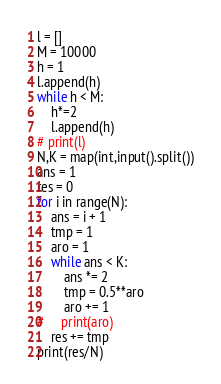<code> <loc_0><loc_0><loc_500><loc_500><_Python_>l = []
M = 10000
h = 1
l.append(h)
while h < M:
    h*=2
    l.append(h)
# print(l)
N,K = map(int,input().split())
ans = 1
res = 0
for i in range(N):
    ans = i + 1
    tmp = 1
    aro = 1
    while ans < K:
        ans *= 2
        tmp = 0.5**aro
        aro += 1
#     print(aro)
    res += tmp
print(res/N)

</code> 